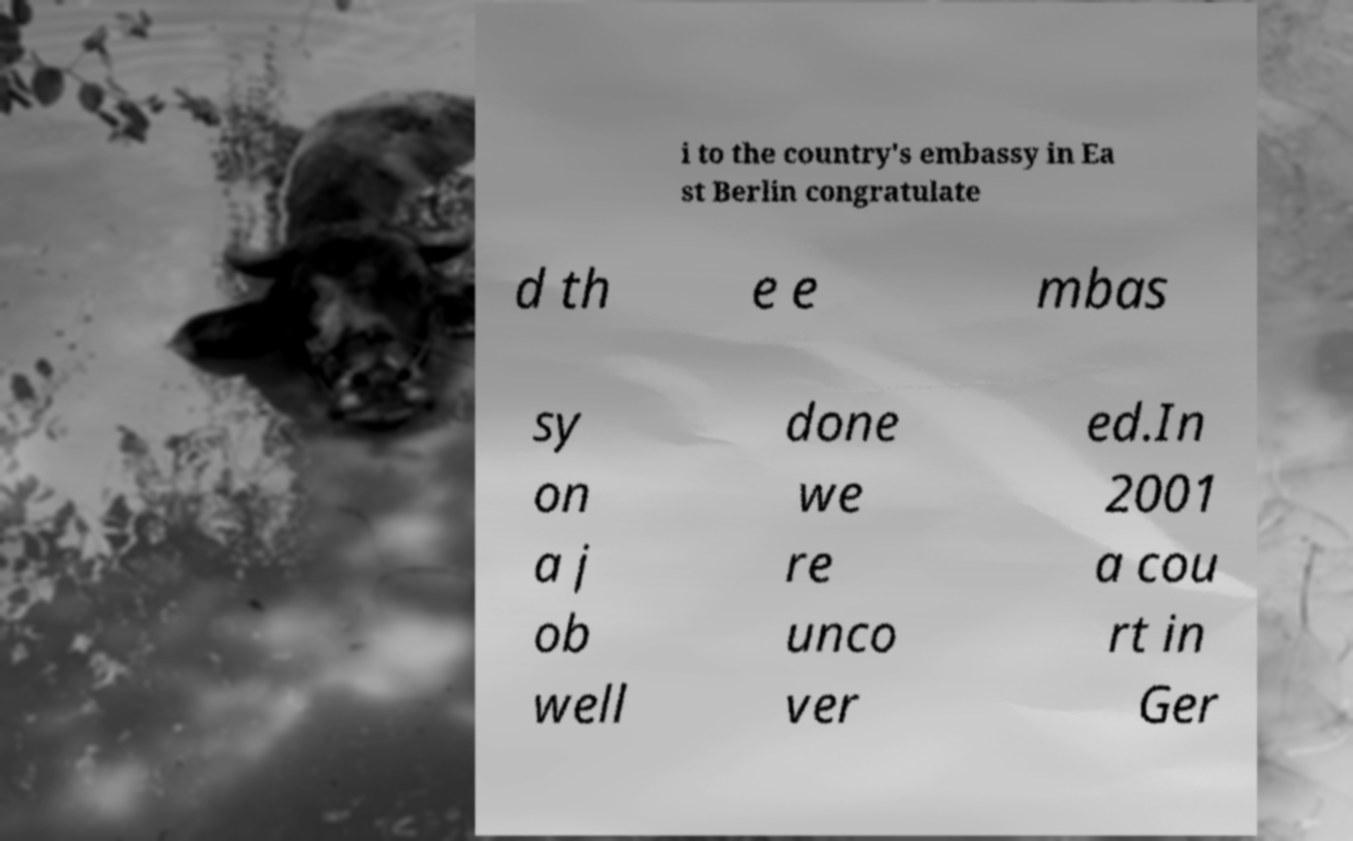There's text embedded in this image that I need extracted. Can you transcribe it verbatim? i to the country's embassy in Ea st Berlin congratulate d th e e mbas sy on a j ob well done we re unco ver ed.In 2001 a cou rt in Ger 